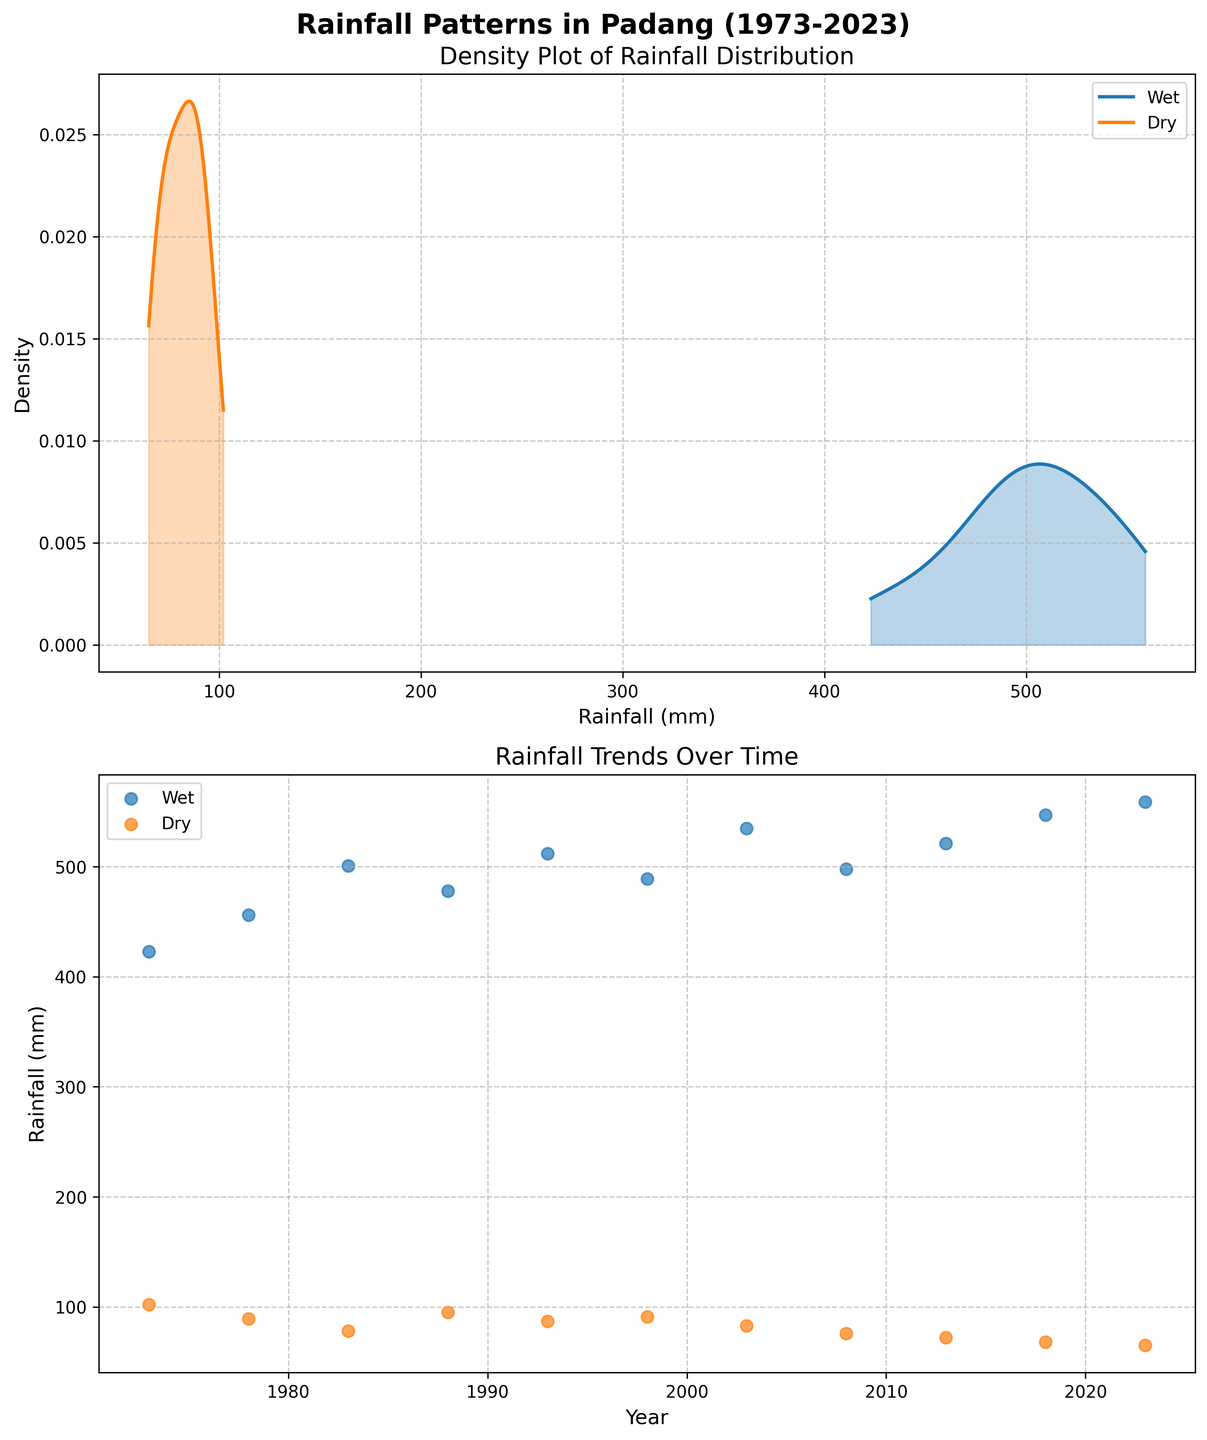What is the title of the figure? The title of the figure is displayed at the top of the plot. It reads "Rainfall Patterns in Padang (1973-2023)"
Answer: Rainfall Patterns in Padang (1973-2023) Which season has a higher density peak in rainfall? By looking at the first subplot, we can observe the height of the density peaks. The 'Wet' season has a higher density peak compared to the 'Dry' season.
Answer: Wet How does the rainfall trend for the 'dry' season change over time? Observing the scatter plot in the second subplot for the 'Dry' season, we see that rainfall decreases steadily from the 1970s to 2023.
Answer: It decreases over time What is the range of rainfall during the wet season? By referencing the x-axis range of the density plot for the 'Wet' season, we can see that the rainfall ranges roughly from 400 mm to 560 mm during the wet season.
Answer: 400 mm to 560 mm Compare the trend of rainfall in the wet season to the dry season over time. In the scatter plots, the 'Wet' season shows a gradual increase in rainfall over time, whereas the 'Dry' season shows a gradual decrease. Both trends are linear but in opposite directions.
Answer: Wet increases, Dry decreases How many distinct data points are shown in the scatter plot for the 'Dry' season? By counting the scatter points labeled for the 'Dry' season in the second subplot, we see there are 11 distinct data points.
Answer: 11 What color represents the wet season in the figure? The wet season is represented by the color blue in both subplots.
Answer: Blue What is the highest value of rainfall recorded during the wet season? By examining the scatter plot for the wet season, we see the highest rainfall value recorded is 559 mm.
Answer: 559 mm Is there any overlap in the density distribution of rainfall between the wet and dry seasons? By observing the density plots, we see that the density curves for the wet and dry seasons do overlap, especially near the lower rainfall values.
Answer: Yes 